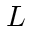Convert formula to latex. <formula><loc_0><loc_0><loc_500><loc_500>L</formula> 